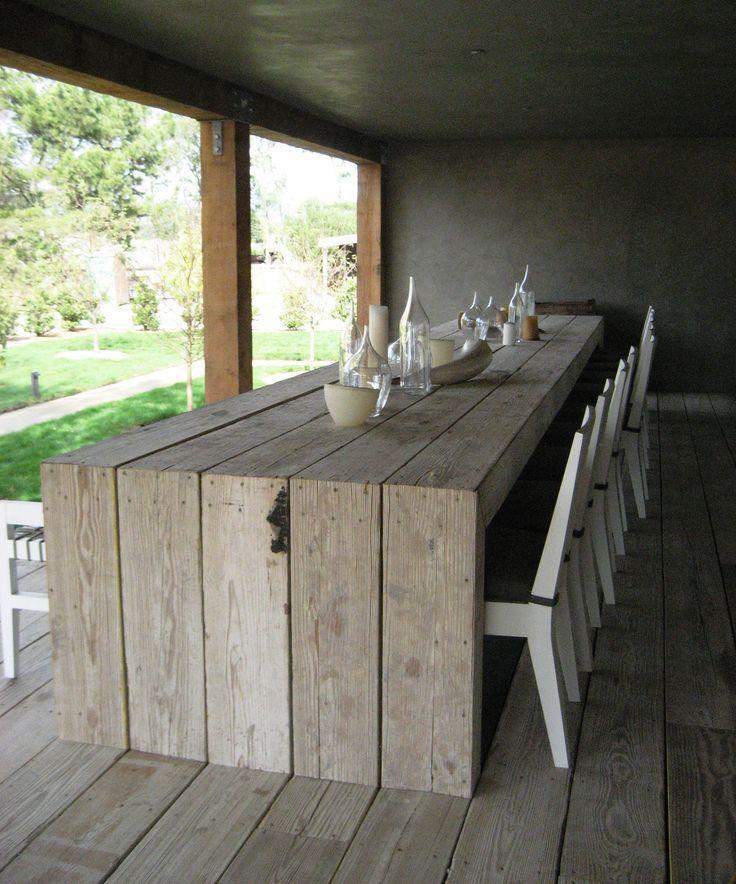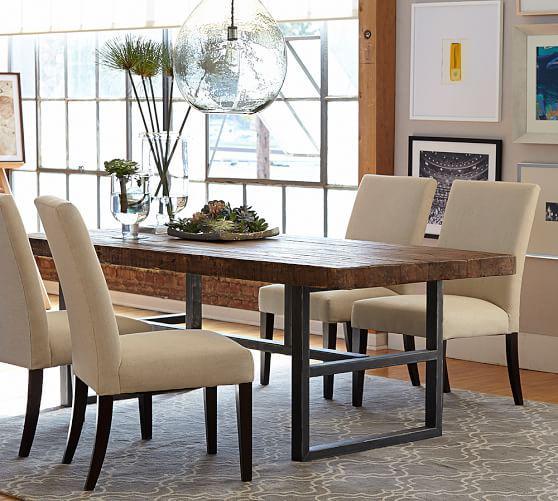The first image is the image on the left, the second image is the image on the right. Evaluate the accuracy of this statement regarding the images: "There are at least two frames on the wall.". Is it true? Answer yes or no. Yes. 